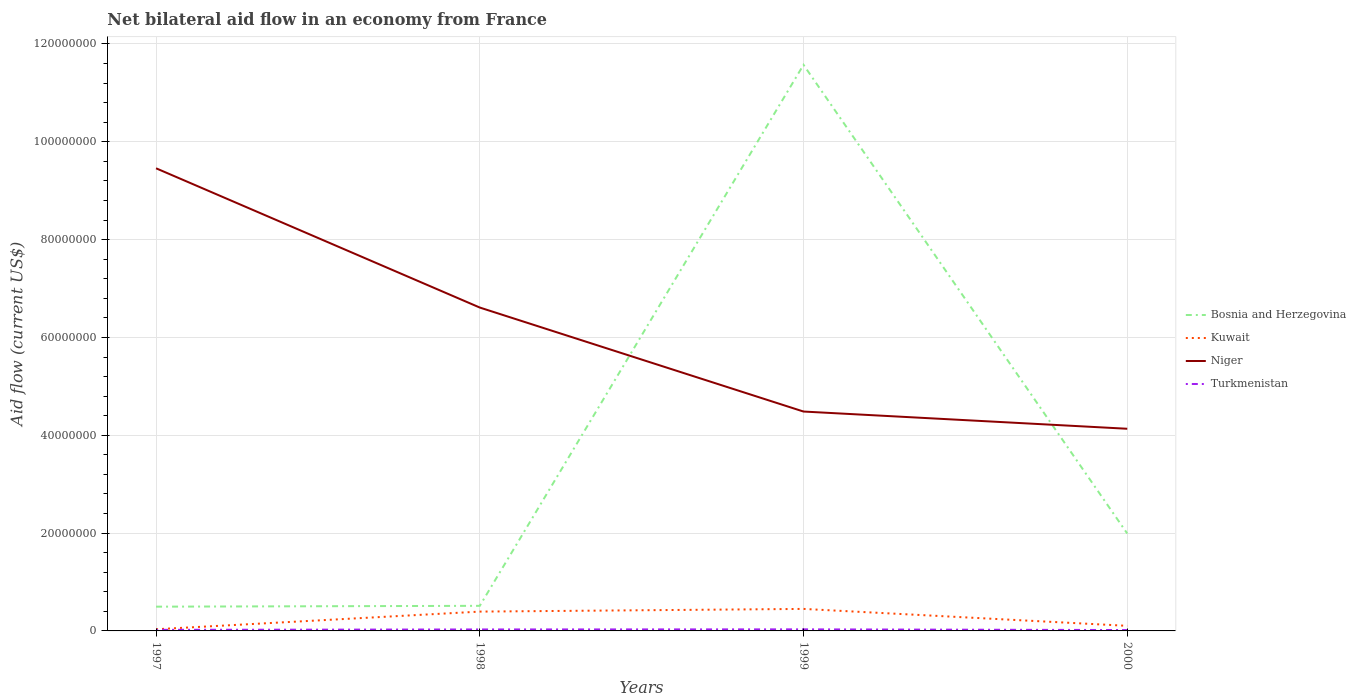How many different coloured lines are there?
Give a very brief answer. 4. Does the line corresponding to Turkmenistan intersect with the line corresponding to Kuwait?
Your answer should be compact. No. Is the number of lines equal to the number of legend labels?
Provide a short and direct response. Yes. Across all years, what is the maximum net bilateral aid flow in Turkmenistan?
Offer a very short reply. 1.80e+05. What is the total net bilateral aid flow in Bosnia and Herzegovina in the graph?
Give a very brief answer. -1.11e+08. What is the difference between the highest and the second highest net bilateral aid flow in Niger?
Make the answer very short. 5.32e+07. Is the net bilateral aid flow in Bosnia and Herzegovina strictly greater than the net bilateral aid flow in Niger over the years?
Keep it short and to the point. No. How many years are there in the graph?
Ensure brevity in your answer.  4. What is the difference between two consecutive major ticks on the Y-axis?
Provide a succinct answer. 2.00e+07. Does the graph contain any zero values?
Make the answer very short. No. Does the graph contain grids?
Your answer should be very brief. Yes. Where does the legend appear in the graph?
Keep it short and to the point. Center right. What is the title of the graph?
Make the answer very short. Net bilateral aid flow in an economy from France. What is the label or title of the X-axis?
Offer a very short reply. Years. What is the Aid flow (current US$) in Bosnia and Herzegovina in 1997?
Your answer should be very brief. 4.96e+06. What is the Aid flow (current US$) in Niger in 1997?
Your response must be concise. 9.46e+07. What is the Aid flow (current US$) of Bosnia and Herzegovina in 1998?
Your answer should be compact. 5.13e+06. What is the Aid flow (current US$) in Kuwait in 1998?
Ensure brevity in your answer.  3.95e+06. What is the Aid flow (current US$) in Niger in 1998?
Your answer should be compact. 6.61e+07. What is the Aid flow (current US$) in Bosnia and Herzegovina in 1999?
Give a very brief answer. 1.16e+08. What is the Aid flow (current US$) of Kuwait in 1999?
Your answer should be very brief. 4.50e+06. What is the Aid flow (current US$) in Niger in 1999?
Provide a succinct answer. 4.48e+07. What is the Aid flow (current US$) of Turkmenistan in 1999?
Offer a terse response. 3.20e+05. What is the Aid flow (current US$) in Bosnia and Herzegovina in 2000?
Your response must be concise. 1.99e+07. What is the Aid flow (current US$) of Kuwait in 2000?
Provide a succinct answer. 1.04e+06. What is the Aid flow (current US$) in Niger in 2000?
Provide a short and direct response. 4.13e+07. What is the Aid flow (current US$) of Turkmenistan in 2000?
Your answer should be very brief. 1.80e+05. Across all years, what is the maximum Aid flow (current US$) of Bosnia and Herzegovina?
Provide a succinct answer. 1.16e+08. Across all years, what is the maximum Aid flow (current US$) of Kuwait?
Your response must be concise. 4.50e+06. Across all years, what is the maximum Aid flow (current US$) of Niger?
Offer a very short reply. 9.46e+07. Across all years, what is the maximum Aid flow (current US$) of Turkmenistan?
Offer a very short reply. 3.20e+05. Across all years, what is the minimum Aid flow (current US$) in Bosnia and Herzegovina?
Your answer should be very brief. 4.96e+06. Across all years, what is the minimum Aid flow (current US$) of Kuwait?
Keep it short and to the point. 3.40e+05. Across all years, what is the minimum Aid flow (current US$) of Niger?
Keep it short and to the point. 4.13e+07. What is the total Aid flow (current US$) of Bosnia and Herzegovina in the graph?
Offer a very short reply. 1.46e+08. What is the total Aid flow (current US$) in Kuwait in the graph?
Give a very brief answer. 9.83e+06. What is the total Aid flow (current US$) of Niger in the graph?
Provide a succinct answer. 2.47e+08. What is the total Aid flow (current US$) of Turkmenistan in the graph?
Offer a terse response. 1.02e+06. What is the difference between the Aid flow (current US$) of Kuwait in 1997 and that in 1998?
Provide a short and direct response. -3.61e+06. What is the difference between the Aid flow (current US$) of Niger in 1997 and that in 1998?
Make the answer very short. 2.85e+07. What is the difference between the Aid flow (current US$) in Turkmenistan in 1997 and that in 1998?
Give a very brief answer. -8.00e+04. What is the difference between the Aid flow (current US$) in Bosnia and Herzegovina in 1997 and that in 1999?
Provide a succinct answer. -1.11e+08. What is the difference between the Aid flow (current US$) in Kuwait in 1997 and that in 1999?
Make the answer very short. -4.16e+06. What is the difference between the Aid flow (current US$) of Niger in 1997 and that in 1999?
Offer a very short reply. 4.97e+07. What is the difference between the Aid flow (current US$) in Turkmenistan in 1997 and that in 1999?
Your answer should be compact. -1.00e+05. What is the difference between the Aid flow (current US$) in Bosnia and Herzegovina in 1997 and that in 2000?
Offer a terse response. -1.50e+07. What is the difference between the Aid flow (current US$) in Kuwait in 1997 and that in 2000?
Ensure brevity in your answer.  -7.00e+05. What is the difference between the Aid flow (current US$) in Niger in 1997 and that in 2000?
Your answer should be compact. 5.32e+07. What is the difference between the Aid flow (current US$) of Bosnia and Herzegovina in 1998 and that in 1999?
Your response must be concise. -1.11e+08. What is the difference between the Aid flow (current US$) in Kuwait in 1998 and that in 1999?
Offer a very short reply. -5.50e+05. What is the difference between the Aid flow (current US$) of Niger in 1998 and that in 1999?
Ensure brevity in your answer.  2.13e+07. What is the difference between the Aid flow (current US$) in Bosnia and Herzegovina in 1998 and that in 2000?
Offer a very short reply. -1.48e+07. What is the difference between the Aid flow (current US$) in Kuwait in 1998 and that in 2000?
Your answer should be compact. 2.91e+06. What is the difference between the Aid flow (current US$) of Niger in 1998 and that in 2000?
Offer a very short reply. 2.48e+07. What is the difference between the Aid flow (current US$) in Turkmenistan in 1998 and that in 2000?
Give a very brief answer. 1.20e+05. What is the difference between the Aid flow (current US$) in Bosnia and Herzegovina in 1999 and that in 2000?
Offer a terse response. 9.58e+07. What is the difference between the Aid flow (current US$) in Kuwait in 1999 and that in 2000?
Offer a very short reply. 3.46e+06. What is the difference between the Aid flow (current US$) in Niger in 1999 and that in 2000?
Keep it short and to the point. 3.52e+06. What is the difference between the Aid flow (current US$) of Bosnia and Herzegovina in 1997 and the Aid flow (current US$) of Kuwait in 1998?
Keep it short and to the point. 1.01e+06. What is the difference between the Aid flow (current US$) in Bosnia and Herzegovina in 1997 and the Aid flow (current US$) in Niger in 1998?
Offer a very short reply. -6.12e+07. What is the difference between the Aid flow (current US$) of Bosnia and Herzegovina in 1997 and the Aid flow (current US$) of Turkmenistan in 1998?
Your response must be concise. 4.66e+06. What is the difference between the Aid flow (current US$) of Kuwait in 1997 and the Aid flow (current US$) of Niger in 1998?
Ensure brevity in your answer.  -6.58e+07. What is the difference between the Aid flow (current US$) in Kuwait in 1997 and the Aid flow (current US$) in Turkmenistan in 1998?
Keep it short and to the point. 4.00e+04. What is the difference between the Aid flow (current US$) in Niger in 1997 and the Aid flow (current US$) in Turkmenistan in 1998?
Keep it short and to the point. 9.43e+07. What is the difference between the Aid flow (current US$) in Bosnia and Herzegovina in 1997 and the Aid flow (current US$) in Niger in 1999?
Give a very brief answer. -3.99e+07. What is the difference between the Aid flow (current US$) in Bosnia and Herzegovina in 1997 and the Aid flow (current US$) in Turkmenistan in 1999?
Give a very brief answer. 4.64e+06. What is the difference between the Aid flow (current US$) in Kuwait in 1997 and the Aid flow (current US$) in Niger in 1999?
Make the answer very short. -4.45e+07. What is the difference between the Aid flow (current US$) in Kuwait in 1997 and the Aid flow (current US$) in Turkmenistan in 1999?
Your answer should be compact. 2.00e+04. What is the difference between the Aid flow (current US$) of Niger in 1997 and the Aid flow (current US$) of Turkmenistan in 1999?
Your answer should be very brief. 9.43e+07. What is the difference between the Aid flow (current US$) in Bosnia and Herzegovina in 1997 and the Aid flow (current US$) in Kuwait in 2000?
Keep it short and to the point. 3.92e+06. What is the difference between the Aid flow (current US$) of Bosnia and Herzegovina in 1997 and the Aid flow (current US$) of Niger in 2000?
Offer a very short reply. -3.64e+07. What is the difference between the Aid flow (current US$) in Bosnia and Herzegovina in 1997 and the Aid flow (current US$) in Turkmenistan in 2000?
Ensure brevity in your answer.  4.78e+06. What is the difference between the Aid flow (current US$) of Kuwait in 1997 and the Aid flow (current US$) of Niger in 2000?
Offer a terse response. -4.10e+07. What is the difference between the Aid flow (current US$) of Kuwait in 1997 and the Aid flow (current US$) of Turkmenistan in 2000?
Provide a succinct answer. 1.60e+05. What is the difference between the Aid flow (current US$) of Niger in 1997 and the Aid flow (current US$) of Turkmenistan in 2000?
Provide a succinct answer. 9.44e+07. What is the difference between the Aid flow (current US$) in Bosnia and Herzegovina in 1998 and the Aid flow (current US$) in Kuwait in 1999?
Your response must be concise. 6.30e+05. What is the difference between the Aid flow (current US$) of Bosnia and Herzegovina in 1998 and the Aid flow (current US$) of Niger in 1999?
Make the answer very short. -3.97e+07. What is the difference between the Aid flow (current US$) in Bosnia and Herzegovina in 1998 and the Aid flow (current US$) in Turkmenistan in 1999?
Your answer should be compact. 4.81e+06. What is the difference between the Aid flow (current US$) in Kuwait in 1998 and the Aid flow (current US$) in Niger in 1999?
Provide a succinct answer. -4.09e+07. What is the difference between the Aid flow (current US$) in Kuwait in 1998 and the Aid flow (current US$) in Turkmenistan in 1999?
Provide a succinct answer. 3.63e+06. What is the difference between the Aid flow (current US$) of Niger in 1998 and the Aid flow (current US$) of Turkmenistan in 1999?
Provide a short and direct response. 6.58e+07. What is the difference between the Aid flow (current US$) of Bosnia and Herzegovina in 1998 and the Aid flow (current US$) of Kuwait in 2000?
Your answer should be very brief. 4.09e+06. What is the difference between the Aid flow (current US$) in Bosnia and Herzegovina in 1998 and the Aid flow (current US$) in Niger in 2000?
Provide a short and direct response. -3.62e+07. What is the difference between the Aid flow (current US$) of Bosnia and Herzegovina in 1998 and the Aid flow (current US$) of Turkmenistan in 2000?
Provide a succinct answer. 4.95e+06. What is the difference between the Aid flow (current US$) in Kuwait in 1998 and the Aid flow (current US$) in Niger in 2000?
Offer a terse response. -3.74e+07. What is the difference between the Aid flow (current US$) of Kuwait in 1998 and the Aid flow (current US$) of Turkmenistan in 2000?
Give a very brief answer. 3.77e+06. What is the difference between the Aid flow (current US$) of Niger in 1998 and the Aid flow (current US$) of Turkmenistan in 2000?
Provide a succinct answer. 6.59e+07. What is the difference between the Aid flow (current US$) of Bosnia and Herzegovina in 1999 and the Aid flow (current US$) of Kuwait in 2000?
Your response must be concise. 1.15e+08. What is the difference between the Aid flow (current US$) of Bosnia and Herzegovina in 1999 and the Aid flow (current US$) of Niger in 2000?
Offer a very short reply. 7.44e+07. What is the difference between the Aid flow (current US$) in Bosnia and Herzegovina in 1999 and the Aid flow (current US$) in Turkmenistan in 2000?
Your answer should be compact. 1.16e+08. What is the difference between the Aid flow (current US$) in Kuwait in 1999 and the Aid flow (current US$) in Niger in 2000?
Your response must be concise. -3.68e+07. What is the difference between the Aid flow (current US$) in Kuwait in 1999 and the Aid flow (current US$) in Turkmenistan in 2000?
Give a very brief answer. 4.32e+06. What is the difference between the Aid flow (current US$) of Niger in 1999 and the Aid flow (current US$) of Turkmenistan in 2000?
Your response must be concise. 4.47e+07. What is the average Aid flow (current US$) of Bosnia and Herzegovina per year?
Your response must be concise. 3.64e+07. What is the average Aid flow (current US$) in Kuwait per year?
Ensure brevity in your answer.  2.46e+06. What is the average Aid flow (current US$) in Niger per year?
Give a very brief answer. 6.17e+07. What is the average Aid flow (current US$) of Turkmenistan per year?
Provide a succinct answer. 2.55e+05. In the year 1997, what is the difference between the Aid flow (current US$) of Bosnia and Herzegovina and Aid flow (current US$) of Kuwait?
Your answer should be very brief. 4.62e+06. In the year 1997, what is the difference between the Aid flow (current US$) in Bosnia and Herzegovina and Aid flow (current US$) in Niger?
Give a very brief answer. -8.96e+07. In the year 1997, what is the difference between the Aid flow (current US$) in Bosnia and Herzegovina and Aid flow (current US$) in Turkmenistan?
Your response must be concise. 4.74e+06. In the year 1997, what is the difference between the Aid flow (current US$) of Kuwait and Aid flow (current US$) of Niger?
Offer a very short reply. -9.42e+07. In the year 1997, what is the difference between the Aid flow (current US$) in Niger and Aid flow (current US$) in Turkmenistan?
Ensure brevity in your answer.  9.44e+07. In the year 1998, what is the difference between the Aid flow (current US$) of Bosnia and Herzegovina and Aid flow (current US$) of Kuwait?
Give a very brief answer. 1.18e+06. In the year 1998, what is the difference between the Aid flow (current US$) in Bosnia and Herzegovina and Aid flow (current US$) in Niger?
Give a very brief answer. -6.10e+07. In the year 1998, what is the difference between the Aid flow (current US$) of Bosnia and Herzegovina and Aid flow (current US$) of Turkmenistan?
Your answer should be compact. 4.83e+06. In the year 1998, what is the difference between the Aid flow (current US$) of Kuwait and Aid flow (current US$) of Niger?
Offer a terse response. -6.22e+07. In the year 1998, what is the difference between the Aid flow (current US$) of Kuwait and Aid flow (current US$) of Turkmenistan?
Provide a short and direct response. 3.65e+06. In the year 1998, what is the difference between the Aid flow (current US$) in Niger and Aid flow (current US$) in Turkmenistan?
Ensure brevity in your answer.  6.58e+07. In the year 1999, what is the difference between the Aid flow (current US$) in Bosnia and Herzegovina and Aid flow (current US$) in Kuwait?
Make the answer very short. 1.11e+08. In the year 1999, what is the difference between the Aid flow (current US$) of Bosnia and Herzegovina and Aid flow (current US$) of Niger?
Your response must be concise. 7.09e+07. In the year 1999, what is the difference between the Aid flow (current US$) of Bosnia and Herzegovina and Aid flow (current US$) of Turkmenistan?
Offer a very short reply. 1.15e+08. In the year 1999, what is the difference between the Aid flow (current US$) of Kuwait and Aid flow (current US$) of Niger?
Your answer should be very brief. -4.04e+07. In the year 1999, what is the difference between the Aid flow (current US$) in Kuwait and Aid flow (current US$) in Turkmenistan?
Keep it short and to the point. 4.18e+06. In the year 1999, what is the difference between the Aid flow (current US$) of Niger and Aid flow (current US$) of Turkmenistan?
Offer a terse response. 4.45e+07. In the year 2000, what is the difference between the Aid flow (current US$) in Bosnia and Herzegovina and Aid flow (current US$) in Kuwait?
Keep it short and to the point. 1.89e+07. In the year 2000, what is the difference between the Aid flow (current US$) in Bosnia and Herzegovina and Aid flow (current US$) in Niger?
Provide a succinct answer. -2.14e+07. In the year 2000, what is the difference between the Aid flow (current US$) in Bosnia and Herzegovina and Aid flow (current US$) in Turkmenistan?
Offer a very short reply. 1.97e+07. In the year 2000, what is the difference between the Aid flow (current US$) of Kuwait and Aid flow (current US$) of Niger?
Give a very brief answer. -4.03e+07. In the year 2000, what is the difference between the Aid flow (current US$) of Kuwait and Aid flow (current US$) of Turkmenistan?
Your answer should be compact. 8.60e+05. In the year 2000, what is the difference between the Aid flow (current US$) in Niger and Aid flow (current US$) in Turkmenistan?
Provide a short and direct response. 4.12e+07. What is the ratio of the Aid flow (current US$) of Bosnia and Herzegovina in 1997 to that in 1998?
Ensure brevity in your answer.  0.97. What is the ratio of the Aid flow (current US$) of Kuwait in 1997 to that in 1998?
Your response must be concise. 0.09. What is the ratio of the Aid flow (current US$) in Niger in 1997 to that in 1998?
Give a very brief answer. 1.43. What is the ratio of the Aid flow (current US$) in Turkmenistan in 1997 to that in 1998?
Your response must be concise. 0.73. What is the ratio of the Aid flow (current US$) of Bosnia and Herzegovina in 1997 to that in 1999?
Provide a succinct answer. 0.04. What is the ratio of the Aid flow (current US$) in Kuwait in 1997 to that in 1999?
Ensure brevity in your answer.  0.08. What is the ratio of the Aid flow (current US$) in Niger in 1997 to that in 1999?
Offer a very short reply. 2.11. What is the ratio of the Aid flow (current US$) in Turkmenistan in 1997 to that in 1999?
Give a very brief answer. 0.69. What is the ratio of the Aid flow (current US$) in Bosnia and Herzegovina in 1997 to that in 2000?
Your answer should be very brief. 0.25. What is the ratio of the Aid flow (current US$) of Kuwait in 1997 to that in 2000?
Give a very brief answer. 0.33. What is the ratio of the Aid flow (current US$) of Niger in 1997 to that in 2000?
Your answer should be compact. 2.29. What is the ratio of the Aid flow (current US$) in Turkmenistan in 1997 to that in 2000?
Ensure brevity in your answer.  1.22. What is the ratio of the Aid flow (current US$) of Bosnia and Herzegovina in 1998 to that in 1999?
Give a very brief answer. 0.04. What is the ratio of the Aid flow (current US$) in Kuwait in 1998 to that in 1999?
Give a very brief answer. 0.88. What is the ratio of the Aid flow (current US$) in Niger in 1998 to that in 1999?
Your answer should be very brief. 1.47. What is the ratio of the Aid flow (current US$) in Turkmenistan in 1998 to that in 1999?
Ensure brevity in your answer.  0.94. What is the ratio of the Aid flow (current US$) in Bosnia and Herzegovina in 1998 to that in 2000?
Provide a short and direct response. 0.26. What is the ratio of the Aid flow (current US$) of Kuwait in 1998 to that in 2000?
Your answer should be very brief. 3.8. What is the ratio of the Aid flow (current US$) of Niger in 1998 to that in 2000?
Offer a terse response. 1.6. What is the ratio of the Aid flow (current US$) in Turkmenistan in 1998 to that in 2000?
Make the answer very short. 1.67. What is the ratio of the Aid flow (current US$) of Bosnia and Herzegovina in 1999 to that in 2000?
Offer a terse response. 5.81. What is the ratio of the Aid flow (current US$) of Kuwait in 1999 to that in 2000?
Your answer should be very brief. 4.33. What is the ratio of the Aid flow (current US$) of Niger in 1999 to that in 2000?
Ensure brevity in your answer.  1.09. What is the ratio of the Aid flow (current US$) of Turkmenistan in 1999 to that in 2000?
Your response must be concise. 1.78. What is the difference between the highest and the second highest Aid flow (current US$) in Bosnia and Herzegovina?
Keep it short and to the point. 9.58e+07. What is the difference between the highest and the second highest Aid flow (current US$) in Niger?
Ensure brevity in your answer.  2.85e+07. What is the difference between the highest and the lowest Aid flow (current US$) in Bosnia and Herzegovina?
Make the answer very short. 1.11e+08. What is the difference between the highest and the lowest Aid flow (current US$) of Kuwait?
Your answer should be very brief. 4.16e+06. What is the difference between the highest and the lowest Aid flow (current US$) of Niger?
Provide a succinct answer. 5.32e+07. What is the difference between the highest and the lowest Aid flow (current US$) of Turkmenistan?
Provide a succinct answer. 1.40e+05. 